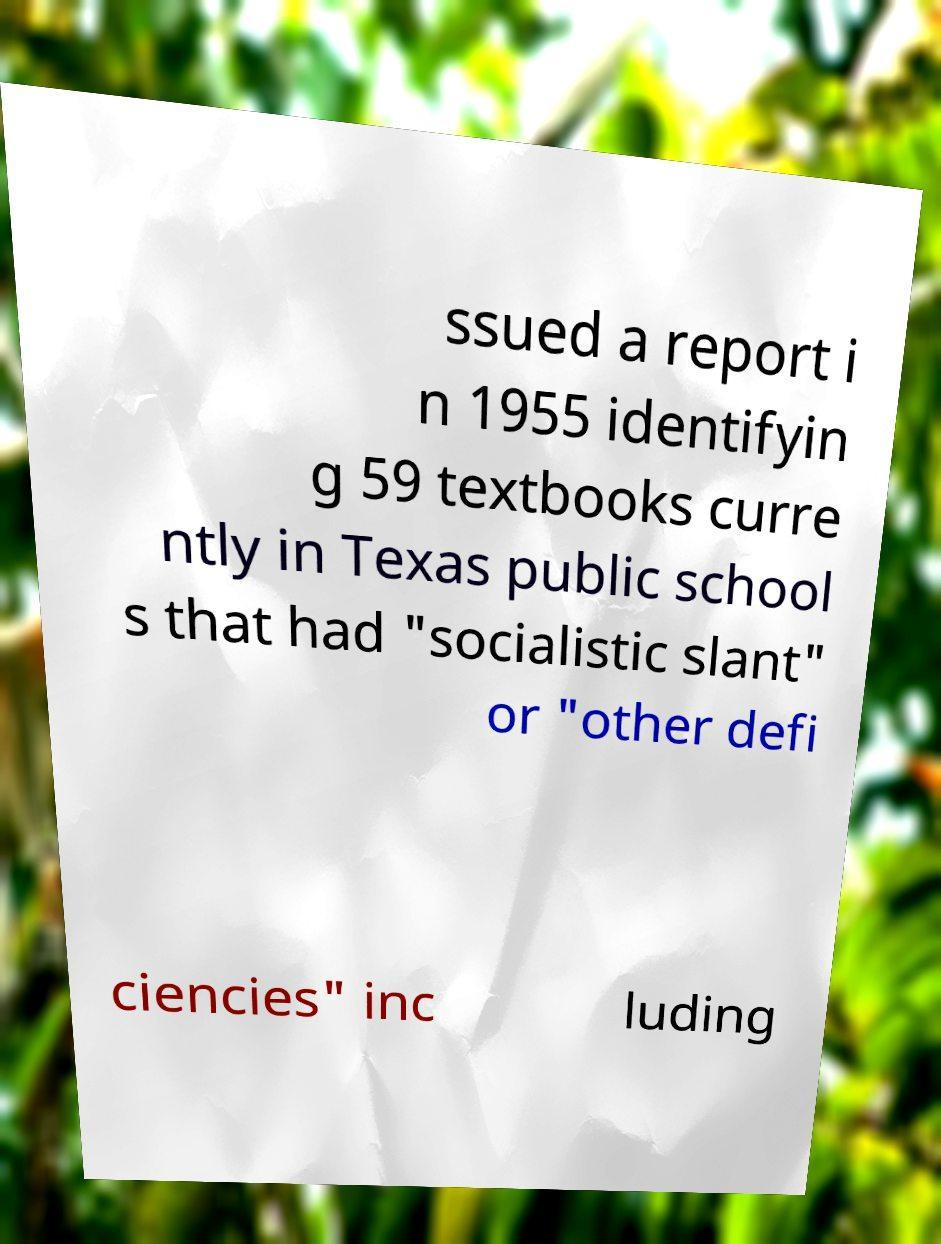For documentation purposes, I need the text within this image transcribed. Could you provide that? ssued a report i n 1955 identifyin g 59 textbooks curre ntly in Texas public school s that had "socialistic slant" or "other defi ciencies" inc luding 